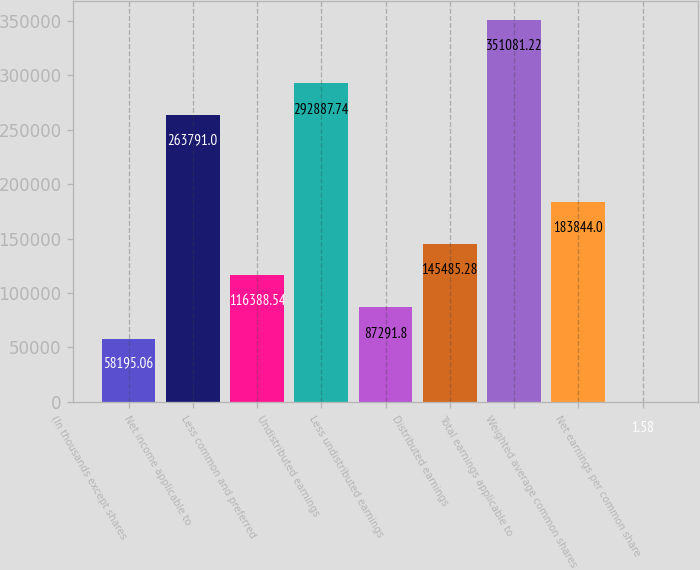Convert chart to OTSL. <chart><loc_0><loc_0><loc_500><loc_500><bar_chart><fcel>(In thousands except shares<fcel>Net income applicable to<fcel>Less common and preferred<fcel>Undistributed earnings<fcel>Less undistributed earnings<fcel>Distributed earnings<fcel>Total earnings applicable to<fcel>Weighted average common shares<fcel>Net earnings per common share<nl><fcel>58195.1<fcel>263791<fcel>116389<fcel>292888<fcel>87291.8<fcel>145485<fcel>351081<fcel>183844<fcel>1.58<nl></chart> 